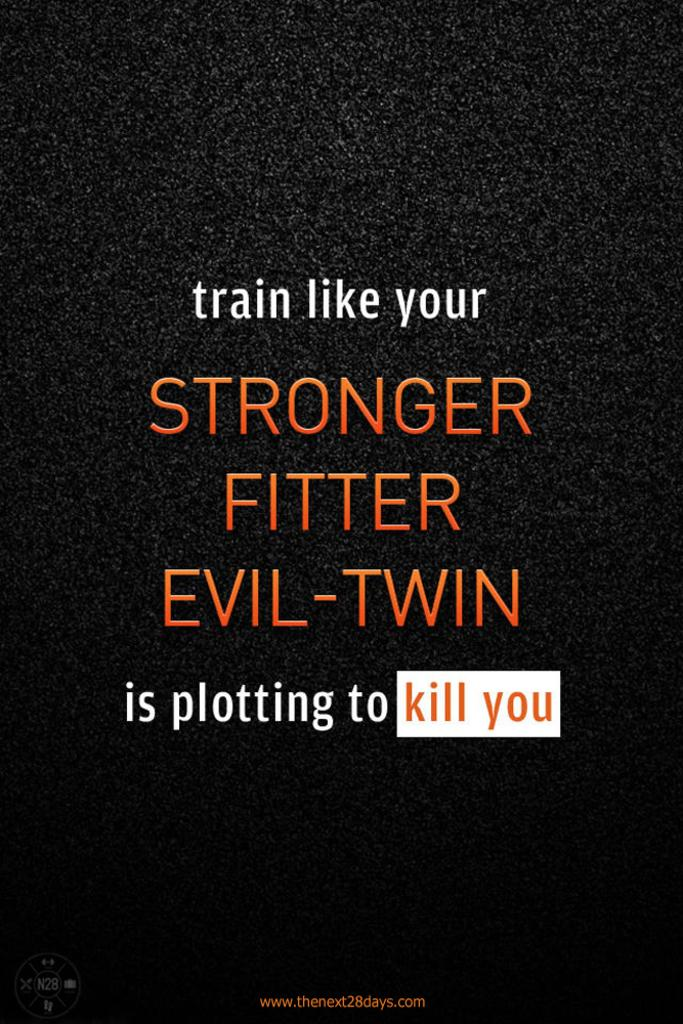<image>
Share a concise interpretation of the image provided. The cover of the book Stronger Fitter Evil-Twin with the website on it. 